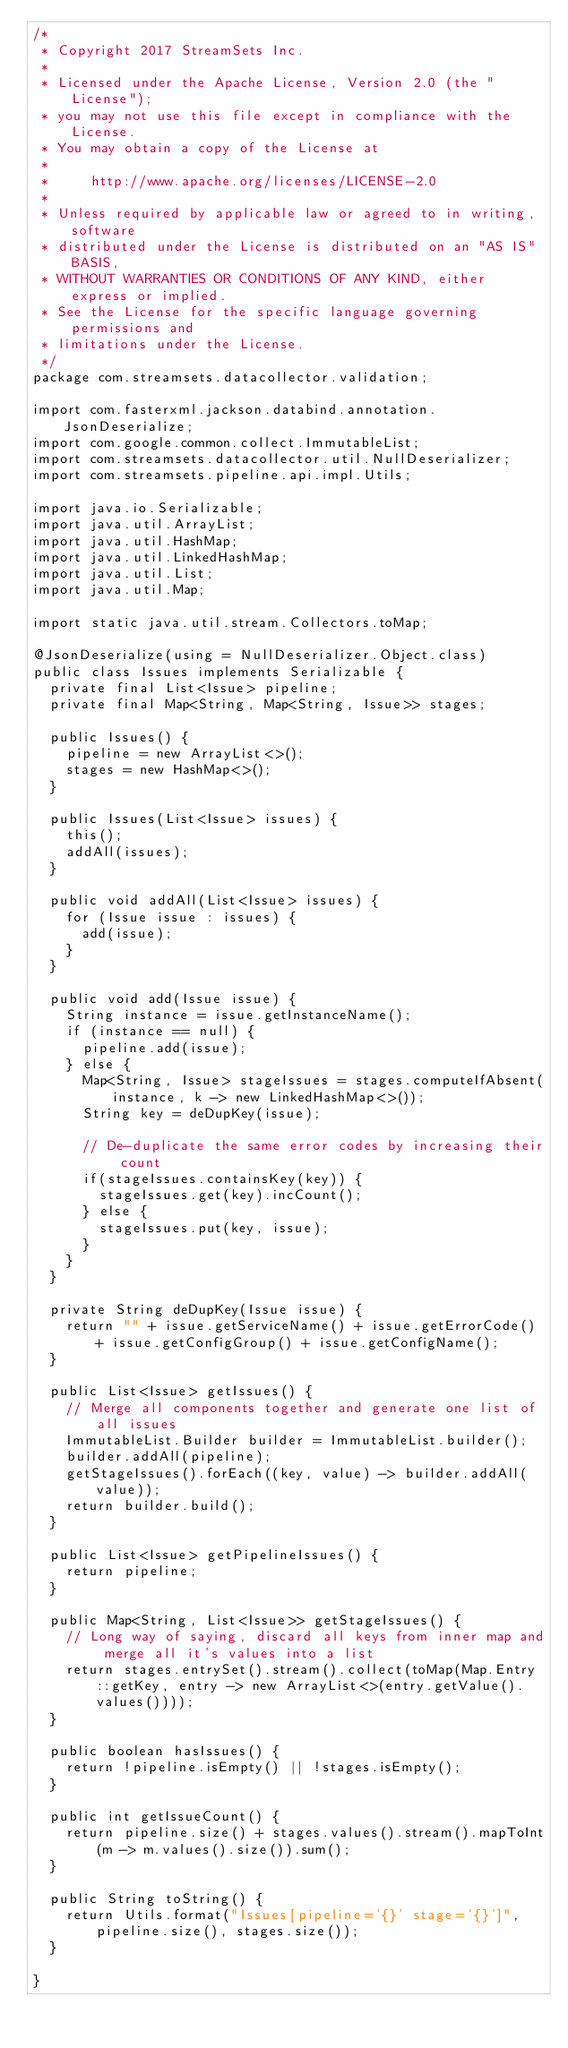Convert code to text. <code><loc_0><loc_0><loc_500><loc_500><_Java_>/*
 * Copyright 2017 StreamSets Inc.
 *
 * Licensed under the Apache License, Version 2.0 (the "License");
 * you may not use this file except in compliance with the License.
 * You may obtain a copy of the License at
 *
 *     http://www.apache.org/licenses/LICENSE-2.0
 *
 * Unless required by applicable law or agreed to in writing, software
 * distributed under the License is distributed on an "AS IS" BASIS,
 * WITHOUT WARRANTIES OR CONDITIONS OF ANY KIND, either express or implied.
 * See the License for the specific language governing permissions and
 * limitations under the License.
 */
package com.streamsets.datacollector.validation;

import com.fasterxml.jackson.databind.annotation.JsonDeserialize;
import com.google.common.collect.ImmutableList;
import com.streamsets.datacollector.util.NullDeserializer;
import com.streamsets.pipeline.api.impl.Utils;

import java.io.Serializable;
import java.util.ArrayList;
import java.util.HashMap;
import java.util.LinkedHashMap;
import java.util.List;
import java.util.Map;

import static java.util.stream.Collectors.toMap;

@JsonDeserialize(using = NullDeserializer.Object.class)
public class Issues implements Serializable {
  private final List<Issue> pipeline;
  private final Map<String, Map<String, Issue>> stages;

  public Issues() {
    pipeline = new ArrayList<>();
    stages = new HashMap<>();
  }

  public Issues(List<Issue> issues) {
    this();
    addAll(issues);
  }

  public void addAll(List<Issue> issues) {
    for (Issue issue : issues) {
      add(issue);
    }
  }

  public void add(Issue issue) {
    String instance = issue.getInstanceName();
    if (instance == null) {
      pipeline.add(issue);
    } else {
      Map<String, Issue> stageIssues = stages.computeIfAbsent(instance, k -> new LinkedHashMap<>());
      String key = deDupKey(issue);

      // De-duplicate the same error codes by increasing their count
      if(stageIssues.containsKey(key)) {
        stageIssues.get(key).incCount();
      } else {
        stageIssues.put(key, issue);
      }
    }
  }

  private String deDupKey(Issue issue) {
    return "" + issue.getServiceName() + issue.getErrorCode() + issue.getConfigGroup() + issue.getConfigName();
  }

  public List<Issue> getIssues() {
    // Merge all components together and generate one list of all issues
    ImmutableList.Builder builder = ImmutableList.builder();
    builder.addAll(pipeline);
    getStageIssues().forEach((key, value) -> builder.addAll(value));
    return builder.build();
  }

  public List<Issue> getPipelineIssues() {
    return pipeline;
  }

  public Map<String, List<Issue>> getStageIssues() {
    // Long way of saying, discard all keys from inner map and merge all it's values into a list
    return stages.entrySet().stream().collect(toMap(Map.Entry::getKey, entry -> new ArrayList<>(entry.getValue().values())));
  }

  public boolean hasIssues() {
    return !pipeline.isEmpty() || !stages.isEmpty();
  }

  public int getIssueCount() {
    return pipeline.size() + stages.values().stream().mapToInt(m -> m.values().size()).sum();
  }

  public String toString() {
    return Utils.format("Issues[pipeline='{}' stage='{}']", pipeline.size(), stages.size());
  }

}
</code> 